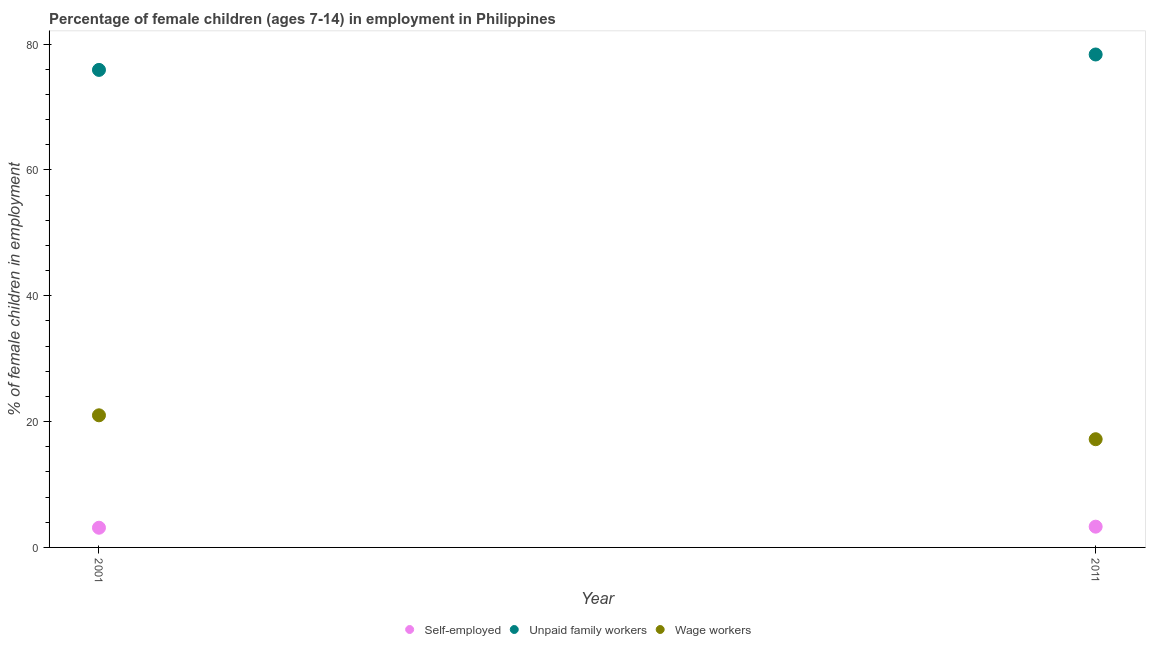Across all years, what is the maximum percentage of children employed as unpaid family workers?
Provide a succinct answer. 78.35. Across all years, what is the minimum percentage of self employed children?
Provide a succinct answer. 3.13. In which year was the percentage of children employed as unpaid family workers minimum?
Offer a very short reply. 2001. What is the total percentage of self employed children in the graph?
Offer a terse response. 6.43. What is the difference between the percentage of children employed as wage workers in 2001 and that in 2011?
Provide a short and direct response. 3.8. What is the difference between the percentage of self employed children in 2011 and the percentage of children employed as wage workers in 2001?
Offer a terse response. -17.7. What is the average percentage of children employed as wage workers per year?
Make the answer very short. 19.1. In the year 2011, what is the difference between the percentage of children employed as wage workers and percentage of children employed as unpaid family workers?
Ensure brevity in your answer.  -61.15. In how many years, is the percentage of self employed children greater than 56 %?
Your answer should be very brief. 0. What is the ratio of the percentage of children employed as unpaid family workers in 2001 to that in 2011?
Provide a succinct answer. 0.97. In how many years, is the percentage of self employed children greater than the average percentage of self employed children taken over all years?
Offer a very short reply. 1. Is the percentage of children employed as unpaid family workers strictly greater than the percentage of self employed children over the years?
Provide a short and direct response. Yes. Is the percentage of children employed as wage workers strictly less than the percentage of children employed as unpaid family workers over the years?
Provide a succinct answer. Yes. What is the difference between two consecutive major ticks on the Y-axis?
Keep it short and to the point. 20. Does the graph contain any zero values?
Make the answer very short. No. Does the graph contain grids?
Make the answer very short. No. Where does the legend appear in the graph?
Give a very brief answer. Bottom center. How many legend labels are there?
Your answer should be compact. 3. What is the title of the graph?
Offer a terse response. Percentage of female children (ages 7-14) in employment in Philippines. What is the label or title of the Y-axis?
Make the answer very short. % of female children in employment. What is the % of female children in employment of Self-employed in 2001?
Offer a terse response. 3.13. What is the % of female children in employment of Unpaid family workers in 2001?
Ensure brevity in your answer.  75.9. What is the % of female children in employment of Wage workers in 2001?
Make the answer very short. 21. What is the % of female children in employment in Self-employed in 2011?
Ensure brevity in your answer.  3.3. What is the % of female children in employment in Unpaid family workers in 2011?
Keep it short and to the point. 78.35. Across all years, what is the maximum % of female children in employment of Self-employed?
Keep it short and to the point. 3.3. Across all years, what is the maximum % of female children in employment of Unpaid family workers?
Provide a succinct answer. 78.35. Across all years, what is the maximum % of female children in employment in Wage workers?
Ensure brevity in your answer.  21. Across all years, what is the minimum % of female children in employment of Self-employed?
Keep it short and to the point. 3.13. Across all years, what is the minimum % of female children in employment in Unpaid family workers?
Give a very brief answer. 75.9. Across all years, what is the minimum % of female children in employment in Wage workers?
Keep it short and to the point. 17.2. What is the total % of female children in employment in Self-employed in the graph?
Your answer should be compact. 6.43. What is the total % of female children in employment in Unpaid family workers in the graph?
Offer a terse response. 154.25. What is the total % of female children in employment of Wage workers in the graph?
Offer a terse response. 38.2. What is the difference between the % of female children in employment of Self-employed in 2001 and that in 2011?
Provide a succinct answer. -0.17. What is the difference between the % of female children in employment in Unpaid family workers in 2001 and that in 2011?
Make the answer very short. -2.45. What is the difference between the % of female children in employment of Wage workers in 2001 and that in 2011?
Give a very brief answer. 3.8. What is the difference between the % of female children in employment of Self-employed in 2001 and the % of female children in employment of Unpaid family workers in 2011?
Your answer should be very brief. -75.22. What is the difference between the % of female children in employment in Self-employed in 2001 and the % of female children in employment in Wage workers in 2011?
Your response must be concise. -14.07. What is the difference between the % of female children in employment of Unpaid family workers in 2001 and the % of female children in employment of Wage workers in 2011?
Offer a very short reply. 58.7. What is the average % of female children in employment of Self-employed per year?
Ensure brevity in your answer.  3.21. What is the average % of female children in employment of Unpaid family workers per year?
Keep it short and to the point. 77.12. What is the average % of female children in employment of Wage workers per year?
Provide a succinct answer. 19.1. In the year 2001, what is the difference between the % of female children in employment of Self-employed and % of female children in employment of Unpaid family workers?
Keep it short and to the point. -72.77. In the year 2001, what is the difference between the % of female children in employment in Self-employed and % of female children in employment in Wage workers?
Keep it short and to the point. -17.87. In the year 2001, what is the difference between the % of female children in employment of Unpaid family workers and % of female children in employment of Wage workers?
Provide a short and direct response. 54.9. In the year 2011, what is the difference between the % of female children in employment of Self-employed and % of female children in employment of Unpaid family workers?
Your response must be concise. -75.05. In the year 2011, what is the difference between the % of female children in employment of Unpaid family workers and % of female children in employment of Wage workers?
Provide a succinct answer. 61.15. What is the ratio of the % of female children in employment in Self-employed in 2001 to that in 2011?
Make the answer very short. 0.95. What is the ratio of the % of female children in employment in Unpaid family workers in 2001 to that in 2011?
Your answer should be very brief. 0.97. What is the ratio of the % of female children in employment of Wage workers in 2001 to that in 2011?
Give a very brief answer. 1.22. What is the difference between the highest and the second highest % of female children in employment of Self-employed?
Ensure brevity in your answer.  0.17. What is the difference between the highest and the second highest % of female children in employment in Unpaid family workers?
Make the answer very short. 2.45. What is the difference between the highest and the lowest % of female children in employment in Self-employed?
Make the answer very short. 0.17. What is the difference between the highest and the lowest % of female children in employment in Unpaid family workers?
Give a very brief answer. 2.45. What is the difference between the highest and the lowest % of female children in employment in Wage workers?
Your answer should be compact. 3.8. 